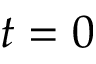Convert formula to latex. <formula><loc_0><loc_0><loc_500><loc_500>t = 0</formula> 